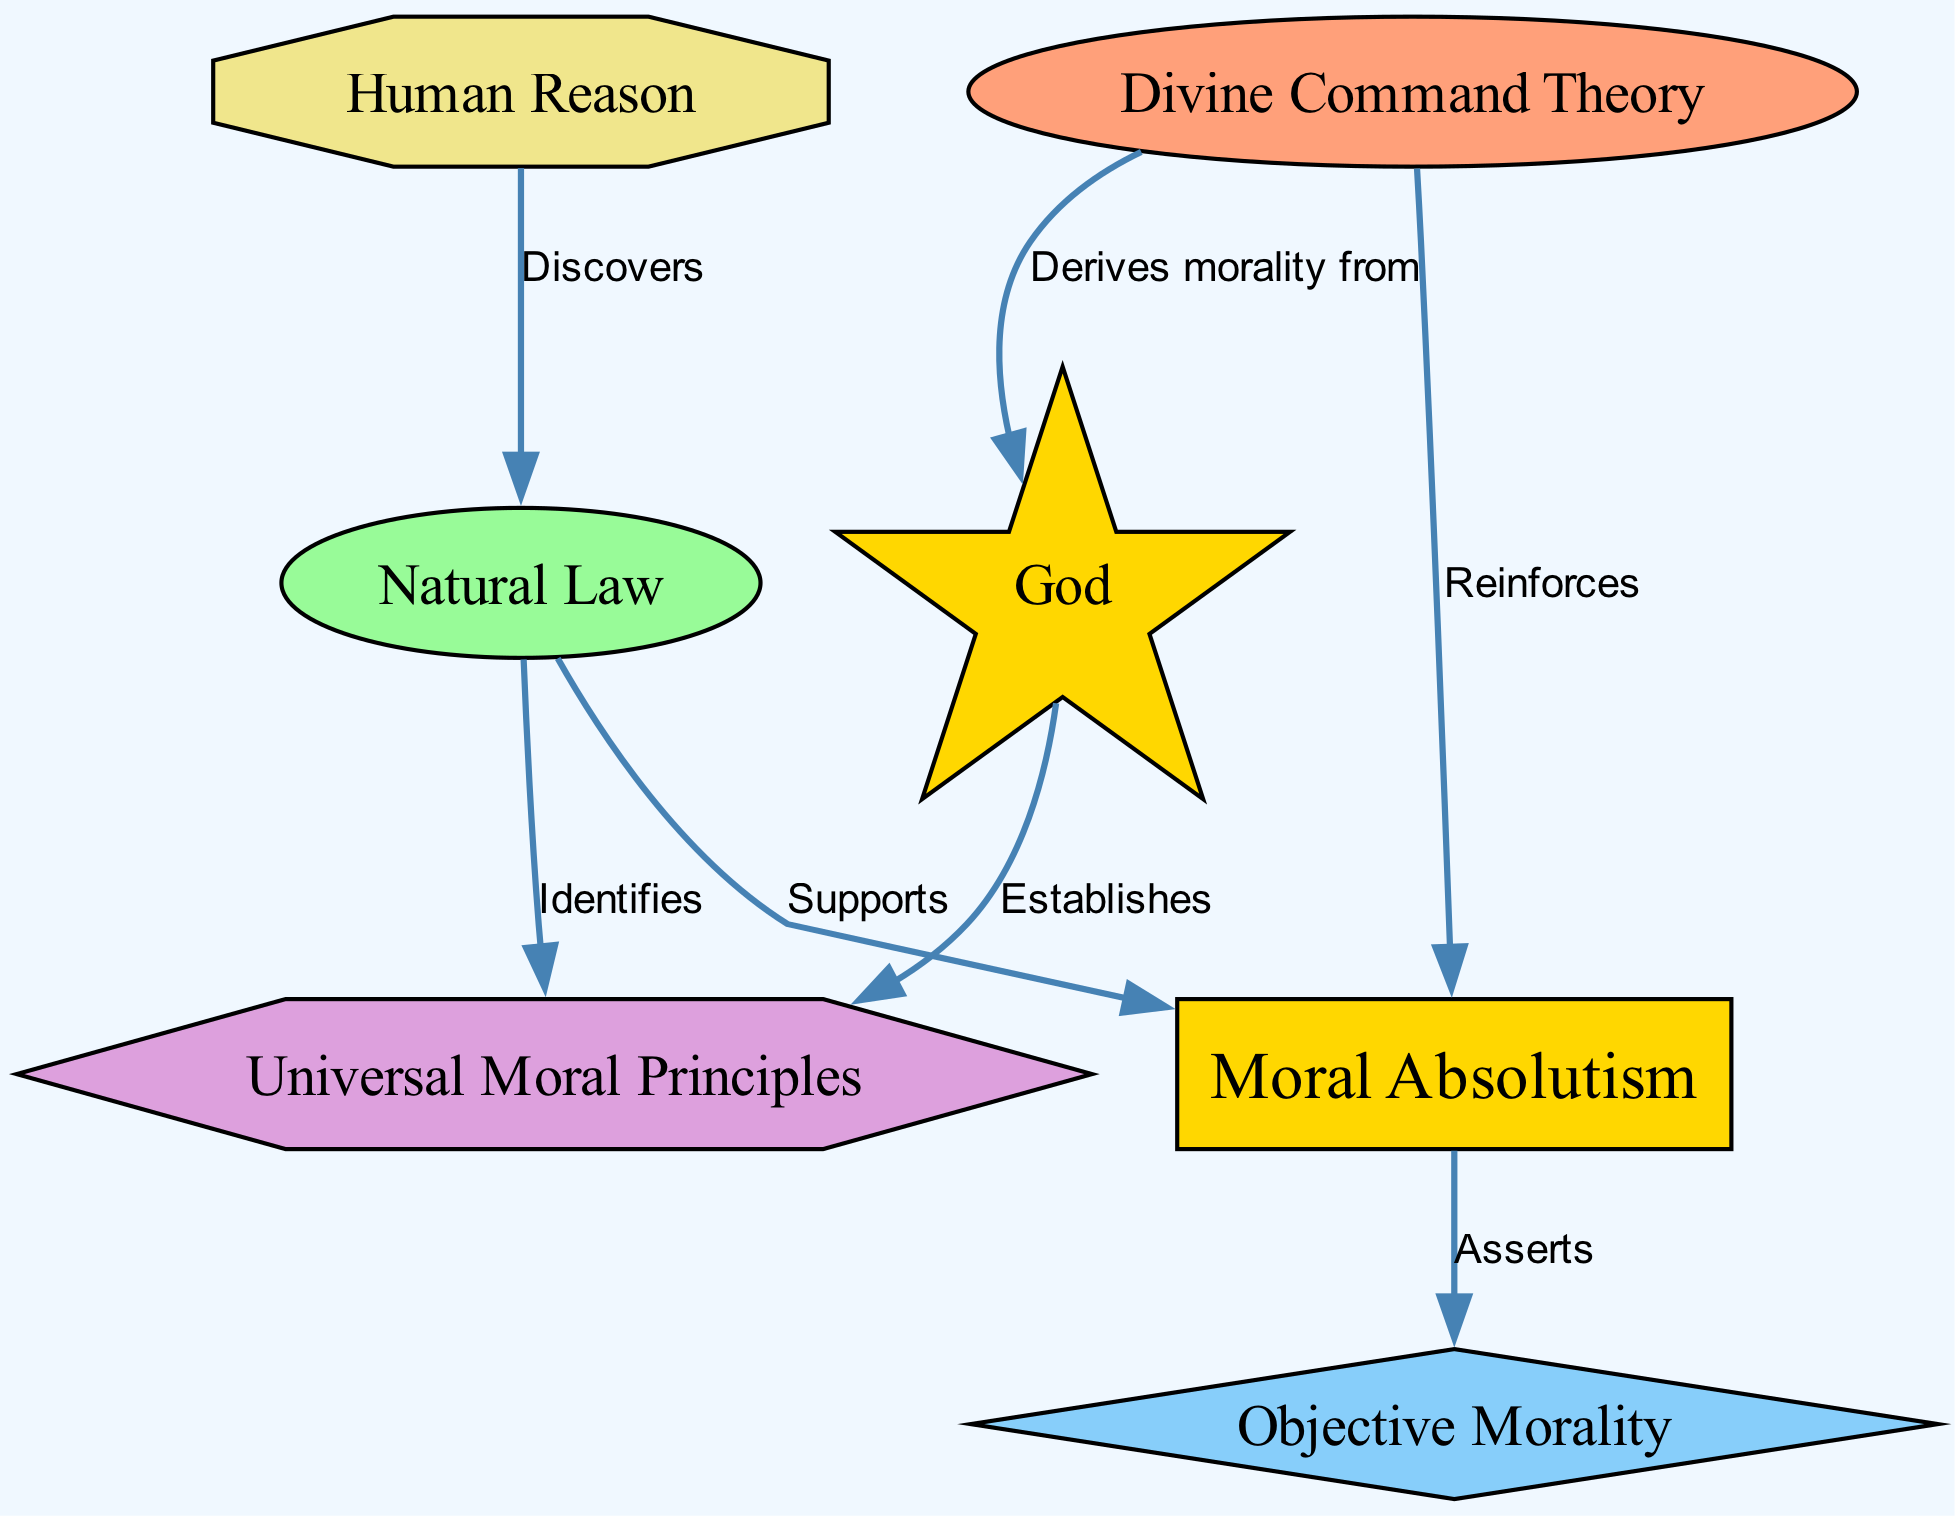What is the total number of nodes in the diagram? There are seven distinct nodes present in the diagram: moral absolutism, natural law, divine command theory, objective morality, universal principles, god, and human reason.
Answer: 7 Which node identifies universal principles? The natural law node identifies universal principles, as indicated by the edge labeled "Identifies" leading from the natural law node to the universal principles node.
Answer: Natural Law What relationship does divine command theory have with moral absolutism? Divine command theory reinforces moral absolutism, as shown by the edge labeled "Reinforces" that connects the divine command theory node to the moral absolutism node.
Answer: Reinforces Which node derives morality from God? The divine command theory node is connected to the God node by the edge labeled "Derives morality from," indicating that it derives morality from God.
Answer: Divine Command Theory What principles does God establish according to the diagram? God establishes universal principles as indicated by the edge labeled "Establishes" leading from the God node to the universal principles node.
Answer: Universal Principles How does human reason relate to natural law? Human reason discovers natural law, which is illustrated by the edge labeled "Discovers" connecting the human reason node to the natural law node.
Answer: Discovers What does moral absolutism assert? Moral absolutism asserts objective morality, as indicated by the edge labeled "Asserts" leading from the moral absolutism node to the objective morality node.
Answer: Objective Morality What type of relationship exists between natural law and moral absolutism? Natural law supports moral absolutism, as indicated by the edge labeled "Supports" that connects the natural law node to the moral absolutism node.
Answer: Supports How many edges are in the diagram? There are six edges connecting the nodes in the diagram, as each edge represents a relationship between paired nodes.
Answer: 6 